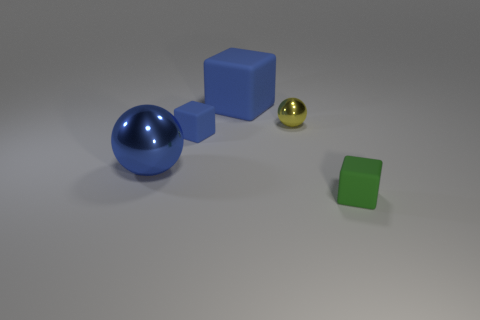Add 1 blue rubber blocks. How many objects exist? 6 Subtract all spheres. How many objects are left? 3 Add 5 metal objects. How many metal objects exist? 7 Subtract 0 brown cylinders. How many objects are left? 5 Subtract all red matte cubes. Subtract all big things. How many objects are left? 3 Add 2 green things. How many green things are left? 3 